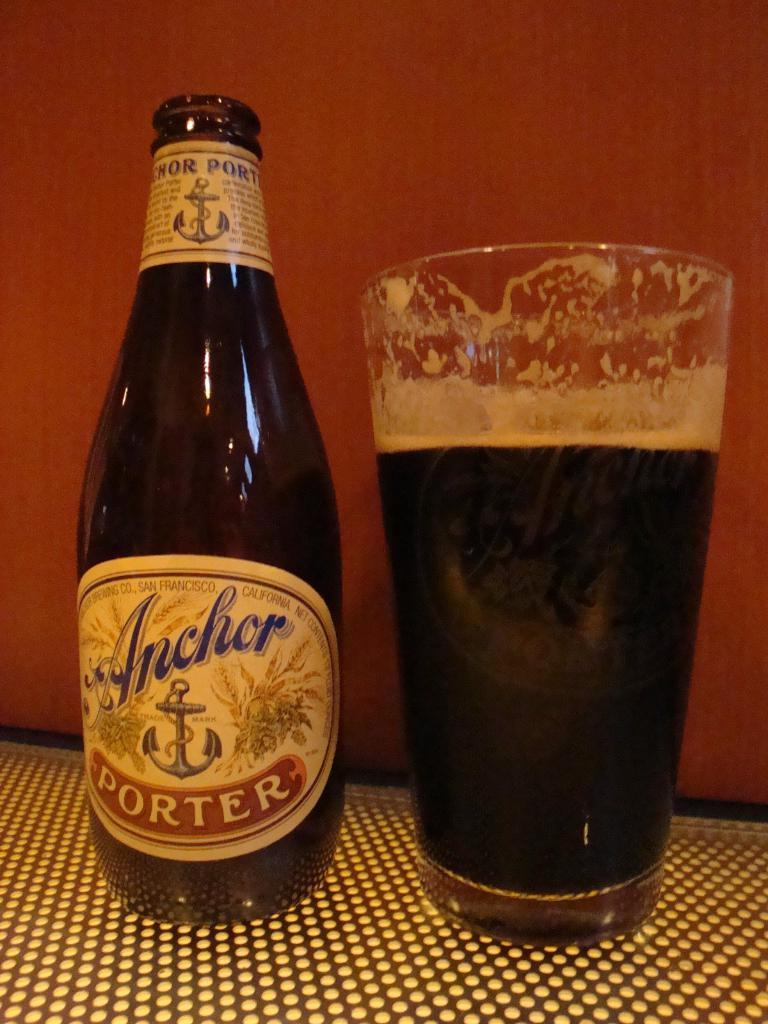What is in the glass that is visible in the image? There is a glass full of juice in the image. What else can be seen on the surface in the image? There is a bottle on the surface in the image. What is the color of the background in the image? The background of the image is orange in color. What information can be found on the bottle in the image? The bottle has a label on it. How does the parent in the image help cure the disease? There is no parent or disease mentioned in the image; it only features a glass of juice, a bottle, and an orange background. What type of bulb is used to illuminate the image? The image is a still photograph and does not require any bulbs for illumination. 